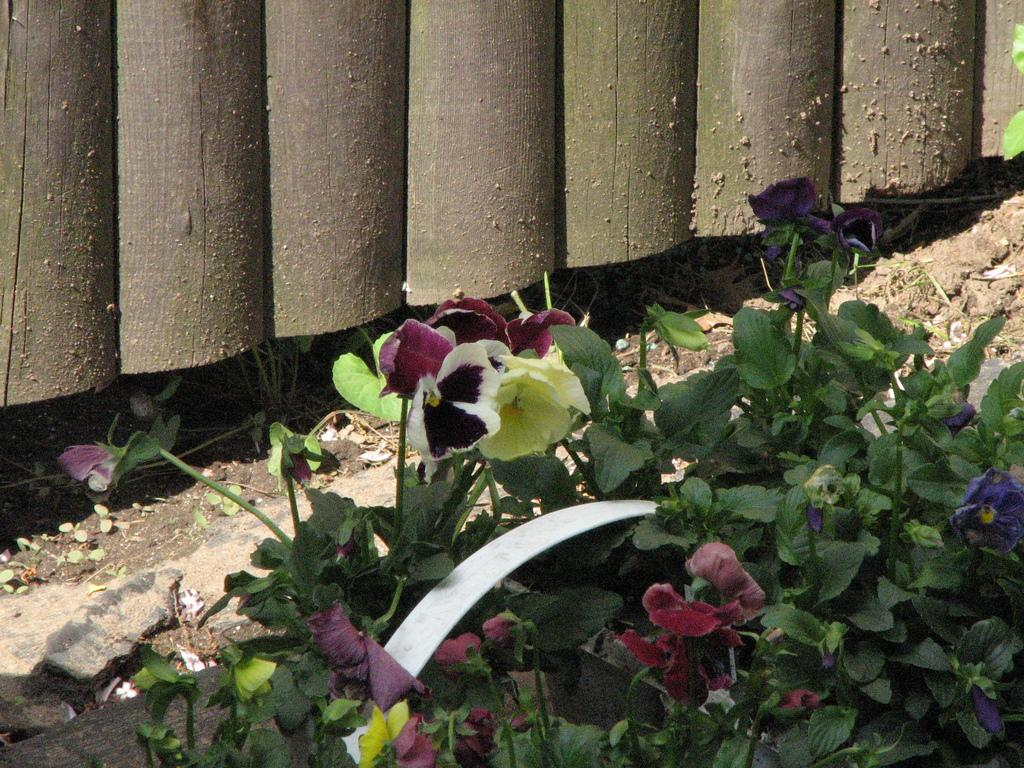What type of living organisms can be seen in the image? There are flowers in the image. What colors are the flowers in the image? The colors of the flowers include purple, white, and yellow. What songs are the bees singing while hovering around the flowers in the image? There are no bees present in the image, so there is no singing or hovering to be observed. 